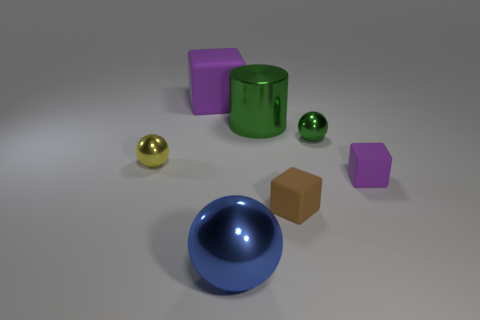What can you infer about the materials the objects are made from? The objects appear to have various materials. The green cylinder and one of the purple cubes have a matte finish, suggesting they are likely made of rubber. The large blue hemisphere has a shiny surface, indicative of plastic or polished metal. The small yellow ball has a reflective surface, characteristic of metal, while the brown cube and small green sphere have a diffuse, non-reflective quality typical of wooden objects. 